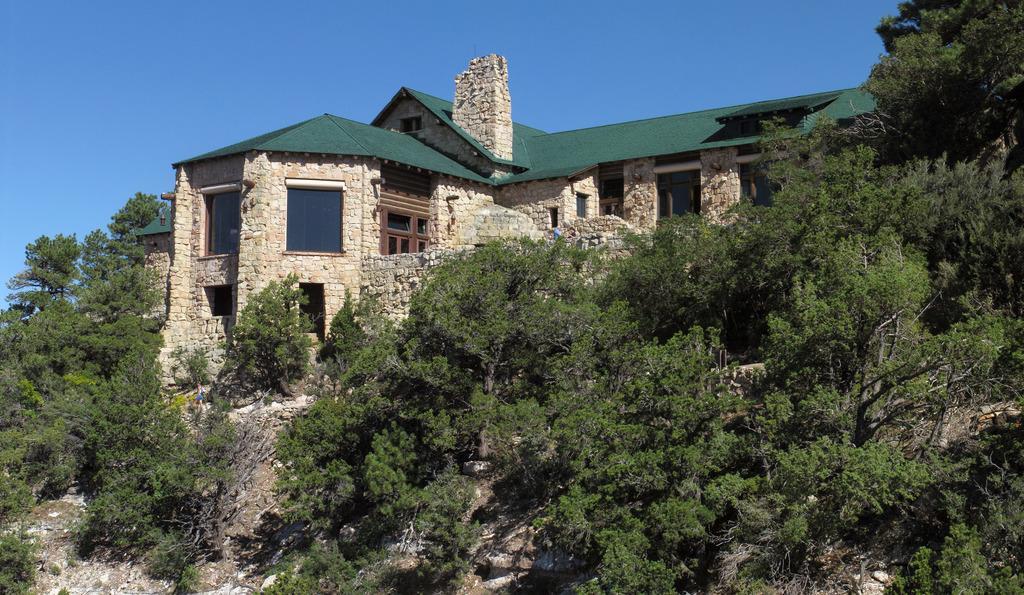Please provide a concise description of this image. In this image we can see trees and a house. In the background there is sky. 